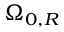Convert formula to latex. <formula><loc_0><loc_0><loc_500><loc_500>\Omega _ { 0 , R }</formula> 